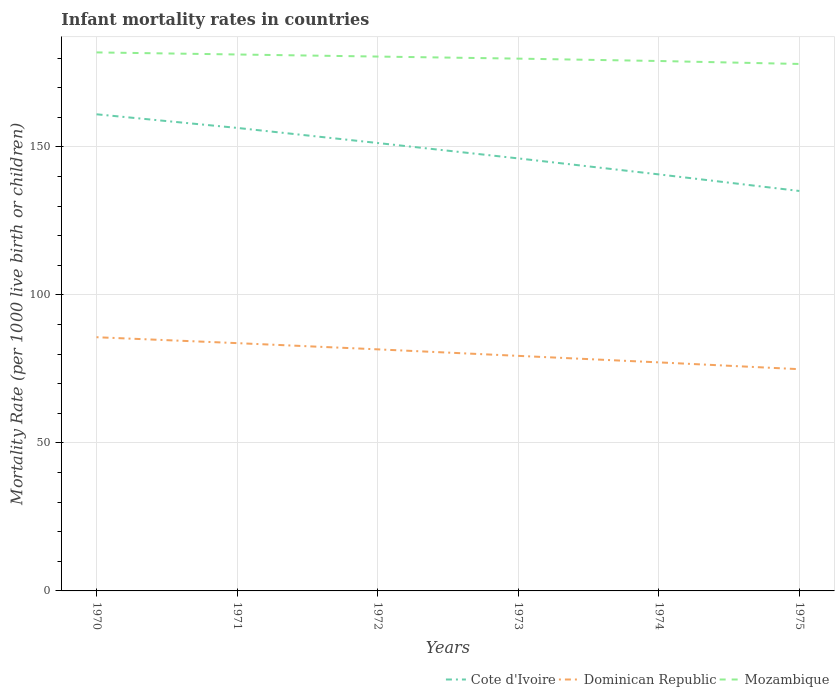Does the line corresponding to Mozambique intersect with the line corresponding to Cote d'Ivoire?
Keep it short and to the point. No. Across all years, what is the maximum infant mortality rate in Cote d'Ivoire?
Your answer should be compact. 135.1. In which year was the infant mortality rate in Dominican Republic maximum?
Make the answer very short. 1975. What is the total infant mortality rate in Dominican Republic in the graph?
Your answer should be compact. 2.2. What is the difference between the highest and the second highest infant mortality rate in Mozambique?
Your answer should be very brief. 3.9. What is the difference between the highest and the lowest infant mortality rate in Mozambique?
Give a very brief answer. 3. How many lines are there?
Offer a very short reply. 3. Does the graph contain grids?
Give a very brief answer. Yes. Where does the legend appear in the graph?
Your response must be concise. Bottom right. How many legend labels are there?
Your answer should be very brief. 3. What is the title of the graph?
Provide a succinct answer. Infant mortality rates in countries. Does "Fiji" appear as one of the legend labels in the graph?
Offer a very short reply. No. What is the label or title of the Y-axis?
Keep it short and to the point. Mortality Rate (per 1000 live birth or children). What is the Mortality Rate (per 1000 live birth or children) of Cote d'Ivoire in 1970?
Make the answer very short. 161. What is the Mortality Rate (per 1000 live birth or children) in Dominican Republic in 1970?
Provide a succinct answer. 85.7. What is the Mortality Rate (per 1000 live birth or children) in Mozambique in 1970?
Give a very brief answer. 181.9. What is the Mortality Rate (per 1000 live birth or children) of Cote d'Ivoire in 1971?
Give a very brief answer. 156.4. What is the Mortality Rate (per 1000 live birth or children) of Dominican Republic in 1971?
Your answer should be compact. 83.7. What is the Mortality Rate (per 1000 live birth or children) in Mozambique in 1971?
Your answer should be very brief. 181.2. What is the Mortality Rate (per 1000 live birth or children) in Cote d'Ivoire in 1972?
Your answer should be compact. 151.3. What is the Mortality Rate (per 1000 live birth or children) of Dominican Republic in 1972?
Your answer should be very brief. 81.6. What is the Mortality Rate (per 1000 live birth or children) of Mozambique in 1972?
Keep it short and to the point. 180.5. What is the Mortality Rate (per 1000 live birth or children) in Cote d'Ivoire in 1973?
Ensure brevity in your answer.  146.1. What is the Mortality Rate (per 1000 live birth or children) in Dominican Republic in 1973?
Your answer should be compact. 79.4. What is the Mortality Rate (per 1000 live birth or children) of Mozambique in 1973?
Keep it short and to the point. 179.8. What is the Mortality Rate (per 1000 live birth or children) in Cote d'Ivoire in 1974?
Give a very brief answer. 140.7. What is the Mortality Rate (per 1000 live birth or children) in Dominican Republic in 1974?
Offer a very short reply. 77.2. What is the Mortality Rate (per 1000 live birth or children) in Mozambique in 1974?
Your response must be concise. 179. What is the Mortality Rate (per 1000 live birth or children) of Cote d'Ivoire in 1975?
Give a very brief answer. 135.1. What is the Mortality Rate (per 1000 live birth or children) in Dominican Republic in 1975?
Keep it short and to the point. 74.9. What is the Mortality Rate (per 1000 live birth or children) of Mozambique in 1975?
Give a very brief answer. 178. Across all years, what is the maximum Mortality Rate (per 1000 live birth or children) in Cote d'Ivoire?
Your response must be concise. 161. Across all years, what is the maximum Mortality Rate (per 1000 live birth or children) in Dominican Republic?
Provide a succinct answer. 85.7. Across all years, what is the maximum Mortality Rate (per 1000 live birth or children) in Mozambique?
Offer a terse response. 181.9. Across all years, what is the minimum Mortality Rate (per 1000 live birth or children) of Cote d'Ivoire?
Give a very brief answer. 135.1. Across all years, what is the minimum Mortality Rate (per 1000 live birth or children) in Dominican Republic?
Keep it short and to the point. 74.9. Across all years, what is the minimum Mortality Rate (per 1000 live birth or children) of Mozambique?
Your answer should be very brief. 178. What is the total Mortality Rate (per 1000 live birth or children) in Cote d'Ivoire in the graph?
Your answer should be compact. 890.6. What is the total Mortality Rate (per 1000 live birth or children) of Dominican Republic in the graph?
Keep it short and to the point. 482.5. What is the total Mortality Rate (per 1000 live birth or children) of Mozambique in the graph?
Your answer should be compact. 1080.4. What is the difference between the Mortality Rate (per 1000 live birth or children) of Cote d'Ivoire in 1970 and that in 1971?
Keep it short and to the point. 4.6. What is the difference between the Mortality Rate (per 1000 live birth or children) of Dominican Republic in 1970 and that in 1972?
Provide a short and direct response. 4.1. What is the difference between the Mortality Rate (per 1000 live birth or children) of Mozambique in 1970 and that in 1972?
Provide a succinct answer. 1.4. What is the difference between the Mortality Rate (per 1000 live birth or children) of Cote d'Ivoire in 1970 and that in 1974?
Make the answer very short. 20.3. What is the difference between the Mortality Rate (per 1000 live birth or children) of Mozambique in 1970 and that in 1974?
Provide a short and direct response. 2.9. What is the difference between the Mortality Rate (per 1000 live birth or children) in Cote d'Ivoire in 1970 and that in 1975?
Offer a very short reply. 25.9. What is the difference between the Mortality Rate (per 1000 live birth or children) in Dominican Republic in 1970 and that in 1975?
Your response must be concise. 10.8. What is the difference between the Mortality Rate (per 1000 live birth or children) of Cote d'Ivoire in 1971 and that in 1972?
Your answer should be very brief. 5.1. What is the difference between the Mortality Rate (per 1000 live birth or children) in Mozambique in 1971 and that in 1972?
Offer a terse response. 0.7. What is the difference between the Mortality Rate (per 1000 live birth or children) in Cote d'Ivoire in 1971 and that in 1973?
Provide a short and direct response. 10.3. What is the difference between the Mortality Rate (per 1000 live birth or children) in Cote d'Ivoire in 1971 and that in 1974?
Offer a terse response. 15.7. What is the difference between the Mortality Rate (per 1000 live birth or children) of Dominican Republic in 1971 and that in 1974?
Make the answer very short. 6.5. What is the difference between the Mortality Rate (per 1000 live birth or children) in Cote d'Ivoire in 1971 and that in 1975?
Offer a terse response. 21.3. What is the difference between the Mortality Rate (per 1000 live birth or children) in Mozambique in 1971 and that in 1975?
Keep it short and to the point. 3.2. What is the difference between the Mortality Rate (per 1000 live birth or children) in Cote d'Ivoire in 1972 and that in 1973?
Your answer should be very brief. 5.2. What is the difference between the Mortality Rate (per 1000 live birth or children) in Dominican Republic in 1972 and that in 1973?
Your answer should be very brief. 2.2. What is the difference between the Mortality Rate (per 1000 live birth or children) in Mozambique in 1972 and that in 1973?
Provide a short and direct response. 0.7. What is the difference between the Mortality Rate (per 1000 live birth or children) of Dominican Republic in 1972 and that in 1974?
Give a very brief answer. 4.4. What is the difference between the Mortality Rate (per 1000 live birth or children) in Dominican Republic in 1972 and that in 1975?
Your response must be concise. 6.7. What is the difference between the Mortality Rate (per 1000 live birth or children) of Cote d'Ivoire in 1973 and that in 1974?
Provide a succinct answer. 5.4. What is the difference between the Mortality Rate (per 1000 live birth or children) of Dominican Republic in 1973 and that in 1974?
Your response must be concise. 2.2. What is the difference between the Mortality Rate (per 1000 live birth or children) of Dominican Republic in 1973 and that in 1975?
Your answer should be compact. 4.5. What is the difference between the Mortality Rate (per 1000 live birth or children) of Mozambique in 1973 and that in 1975?
Keep it short and to the point. 1.8. What is the difference between the Mortality Rate (per 1000 live birth or children) of Dominican Republic in 1974 and that in 1975?
Your answer should be very brief. 2.3. What is the difference between the Mortality Rate (per 1000 live birth or children) of Cote d'Ivoire in 1970 and the Mortality Rate (per 1000 live birth or children) of Dominican Republic in 1971?
Give a very brief answer. 77.3. What is the difference between the Mortality Rate (per 1000 live birth or children) of Cote d'Ivoire in 1970 and the Mortality Rate (per 1000 live birth or children) of Mozambique in 1971?
Offer a very short reply. -20.2. What is the difference between the Mortality Rate (per 1000 live birth or children) of Dominican Republic in 1970 and the Mortality Rate (per 1000 live birth or children) of Mozambique in 1971?
Offer a very short reply. -95.5. What is the difference between the Mortality Rate (per 1000 live birth or children) of Cote d'Ivoire in 1970 and the Mortality Rate (per 1000 live birth or children) of Dominican Republic in 1972?
Provide a succinct answer. 79.4. What is the difference between the Mortality Rate (per 1000 live birth or children) in Cote d'Ivoire in 1970 and the Mortality Rate (per 1000 live birth or children) in Mozambique in 1972?
Your answer should be very brief. -19.5. What is the difference between the Mortality Rate (per 1000 live birth or children) of Dominican Republic in 1970 and the Mortality Rate (per 1000 live birth or children) of Mozambique in 1972?
Make the answer very short. -94.8. What is the difference between the Mortality Rate (per 1000 live birth or children) of Cote d'Ivoire in 1970 and the Mortality Rate (per 1000 live birth or children) of Dominican Republic in 1973?
Keep it short and to the point. 81.6. What is the difference between the Mortality Rate (per 1000 live birth or children) of Cote d'Ivoire in 1970 and the Mortality Rate (per 1000 live birth or children) of Mozambique in 1973?
Your response must be concise. -18.8. What is the difference between the Mortality Rate (per 1000 live birth or children) in Dominican Republic in 1970 and the Mortality Rate (per 1000 live birth or children) in Mozambique in 1973?
Give a very brief answer. -94.1. What is the difference between the Mortality Rate (per 1000 live birth or children) of Cote d'Ivoire in 1970 and the Mortality Rate (per 1000 live birth or children) of Dominican Republic in 1974?
Provide a short and direct response. 83.8. What is the difference between the Mortality Rate (per 1000 live birth or children) of Cote d'Ivoire in 1970 and the Mortality Rate (per 1000 live birth or children) of Mozambique in 1974?
Offer a terse response. -18. What is the difference between the Mortality Rate (per 1000 live birth or children) of Dominican Republic in 1970 and the Mortality Rate (per 1000 live birth or children) of Mozambique in 1974?
Offer a very short reply. -93.3. What is the difference between the Mortality Rate (per 1000 live birth or children) of Cote d'Ivoire in 1970 and the Mortality Rate (per 1000 live birth or children) of Dominican Republic in 1975?
Offer a very short reply. 86.1. What is the difference between the Mortality Rate (per 1000 live birth or children) of Cote d'Ivoire in 1970 and the Mortality Rate (per 1000 live birth or children) of Mozambique in 1975?
Your answer should be compact. -17. What is the difference between the Mortality Rate (per 1000 live birth or children) in Dominican Republic in 1970 and the Mortality Rate (per 1000 live birth or children) in Mozambique in 1975?
Your answer should be very brief. -92.3. What is the difference between the Mortality Rate (per 1000 live birth or children) of Cote d'Ivoire in 1971 and the Mortality Rate (per 1000 live birth or children) of Dominican Republic in 1972?
Ensure brevity in your answer.  74.8. What is the difference between the Mortality Rate (per 1000 live birth or children) of Cote d'Ivoire in 1971 and the Mortality Rate (per 1000 live birth or children) of Mozambique in 1972?
Your answer should be compact. -24.1. What is the difference between the Mortality Rate (per 1000 live birth or children) of Dominican Republic in 1971 and the Mortality Rate (per 1000 live birth or children) of Mozambique in 1972?
Give a very brief answer. -96.8. What is the difference between the Mortality Rate (per 1000 live birth or children) in Cote d'Ivoire in 1971 and the Mortality Rate (per 1000 live birth or children) in Dominican Republic in 1973?
Provide a short and direct response. 77. What is the difference between the Mortality Rate (per 1000 live birth or children) in Cote d'Ivoire in 1971 and the Mortality Rate (per 1000 live birth or children) in Mozambique in 1973?
Your response must be concise. -23.4. What is the difference between the Mortality Rate (per 1000 live birth or children) in Dominican Republic in 1971 and the Mortality Rate (per 1000 live birth or children) in Mozambique in 1973?
Your answer should be very brief. -96.1. What is the difference between the Mortality Rate (per 1000 live birth or children) of Cote d'Ivoire in 1971 and the Mortality Rate (per 1000 live birth or children) of Dominican Republic in 1974?
Ensure brevity in your answer.  79.2. What is the difference between the Mortality Rate (per 1000 live birth or children) in Cote d'Ivoire in 1971 and the Mortality Rate (per 1000 live birth or children) in Mozambique in 1974?
Offer a very short reply. -22.6. What is the difference between the Mortality Rate (per 1000 live birth or children) in Dominican Republic in 1971 and the Mortality Rate (per 1000 live birth or children) in Mozambique in 1974?
Ensure brevity in your answer.  -95.3. What is the difference between the Mortality Rate (per 1000 live birth or children) in Cote d'Ivoire in 1971 and the Mortality Rate (per 1000 live birth or children) in Dominican Republic in 1975?
Offer a terse response. 81.5. What is the difference between the Mortality Rate (per 1000 live birth or children) in Cote d'Ivoire in 1971 and the Mortality Rate (per 1000 live birth or children) in Mozambique in 1975?
Your answer should be compact. -21.6. What is the difference between the Mortality Rate (per 1000 live birth or children) of Dominican Republic in 1971 and the Mortality Rate (per 1000 live birth or children) of Mozambique in 1975?
Your answer should be compact. -94.3. What is the difference between the Mortality Rate (per 1000 live birth or children) in Cote d'Ivoire in 1972 and the Mortality Rate (per 1000 live birth or children) in Dominican Republic in 1973?
Keep it short and to the point. 71.9. What is the difference between the Mortality Rate (per 1000 live birth or children) in Cote d'Ivoire in 1972 and the Mortality Rate (per 1000 live birth or children) in Mozambique in 1973?
Your answer should be very brief. -28.5. What is the difference between the Mortality Rate (per 1000 live birth or children) of Dominican Republic in 1972 and the Mortality Rate (per 1000 live birth or children) of Mozambique in 1973?
Make the answer very short. -98.2. What is the difference between the Mortality Rate (per 1000 live birth or children) of Cote d'Ivoire in 1972 and the Mortality Rate (per 1000 live birth or children) of Dominican Republic in 1974?
Keep it short and to the point. 74.1. What is the difference between the Mortality Rate (per 1000 live birth or children) in Cote d'Ivoire in 1972 and the Mortality Rate (per 1000 live birth or children) in Mozambique in 1974?
Provide a succinct answer. -27.7. What is the difference between the Mortality Rate (per 1000 live birth or children) of Dominican Republic in 1972 and the Mortality Rate (per 1000 live birth or children) of Mozambique in 1974?
Ensure brevity in your answer.  -97.4. What is the difference between the Mortality Rate (per 1000 live birth or children) of Cote d'Ivoire in 1972 and the Mortality Rate (per 1000 live birth or children) of Dominican Republic in 1975?
Your answer should be compact. 76.4. What is the difference between the Mortality Rate (per 1000 live birth or children) of Cote d'Ivoire in 1972 and the Mortality Rate (per 1000 live birth or children) of Mozambique in 1975?
Give a very brief answer. -26.7. What is the difference between the Mortality Rate (per 1000 live birth or children) in Dominican Republic in 1972 and the Mortality Rate (per 1000 live birth or children) in Mozambique in 1975?
Your answer should be compact. -96.4. What is the difference between the Mortality Rate (per 1000 live birth or children) in Cote d'Ivoire in 1973 and the Mortality Rate (per 1000 live birth or children) in Dominican Republic in 1974?
Offer a very short reply. 68.9. What is the difference between the Mortality Rate (per 1000 live birth or children) of Cote d'Ivoire in 1973 and the Mortality Rate (per 1000 live birth or children) of Mozambique in 1974?
Ensure brevity in your answer.  -32.9. What is the difference between the Mortality Rate (per 1000 live birth or children) of Dominican Republic in 1973 and the Mortality Rate (per 1000 live birth or children) of Mozambique in 1974?
Your answer should be very brief. -99.6. What is the difference between the Mortality Rate (per 1000 live birth or children) of Cote d'Ivoire in 1973 and the Mortality Rate (per 1000 live birth or children) of Dominican Republic in 1975?
Give a very brief answer. 71.2. What is the difference between the Mortality Rate (per 1000 live birth or children) in Cote d'Ivoire in 1973 and the Mortality Rate (per 1000 live birth or children) in Mozambique in 1975?
Keep it short and to the point. -31.9. What is the difference between the Mortality Rate (per 1000 live birth or children) of Dominican Republic in 1973 and the Mortality Rate (per 1000 live birth or children) of Mozambique in 1975?
Give a very brief answer. -98.6. What is the difference between the Mortality Rate (per 1000 live birth or children) of Cote d'Ivoire in 1974 and the Mortality Rate (per 1000 live birth or children) of Dominican Republic in 1975?
Ensure brevity in your answer.  65.8. What is the difference between the Mortality Rate (per 1000 live birth or children) of Cote d'Ivoire in 1974 and the Mortality Rate (per 1000 live birth or children) of Mozambique in 1975?
Give a very brief answer. -37.3. What is the difference between the Mortality Rate (per 1000 live birth or children) of Dominican Republic in 1974 and the Mortality Rate (per 1000 live birth or children) of Mozambique in 1975?
Make the answer very short. -100.8. What is the average Mortality Rate (per 1000 live birth or children) in Cote d'Ivoire per year?
Offer a very short reply. 148.43. What is the average Mortality Rate (per 1000 live birth or children) of Dominican Republic per year?
Your answer should be compact. 80.42. What is the average Mortality Rate (per 1000 live birth or children) in Mozambique per year?
Provide a succinct answer. 180.07. In the year 1970, what is the difference between the Mortality Rate (per 1000 live birth or children) in Cote d'Ivoire and Mortality Rate (per 1000 live birth or children) in Dominican Republic?
Ensure brevity in your answer.  75.3. In the year 1970, what is the difference between the Mortality Rate (per 1000 live birth or children) of Cote d'Ivoire and Mortality Rate (per 1000 live birth or children) of Mozambique?
Your response must be concise. -20.9. In the year 1970, what is the difference between the Mortality Rate (per 1000 live birth or children) in Dominican Republic and Mortality Rate (per 1000 live birth or children) in Mozambique?
Your answer should be very brief. -96.2. In the year 1971, what is the difference between the Mortality Rate (per 1000 live birth or children) of Cote d'Ivoire and Mortality Rate (per 1000 live birth or children) of Dominican Republic?
Make the answer very short. 72.7. In the year 1971, what is the difference between the Mortality Rate (per 1000 live birth or children) of Cote d'Ivoire and Mortality Rate (per 1000 live birth or children) of Mozambique?
Your answer should be very brief. -24.8. In the year 1971, what is the difference between the Mortality Rate (per 1000 live birth or children) of Dominican Republic and Mortality Rate (per 1000 live birth or children) of Mozambique?
Offer a terse response. -97.5. In the year 1972, what is the difference between the Mortality Rate (per 1000 live birth or children) in Cote d'Ivoire and Mortality Rate (per 1000 live birth or children) in Dominican Republic?
Keep it short and to the point. 69.7. In the year 1972, what is the difference between the Mortality Rate (per 1000 live birth or children) in Cote d'Ivoire and Mortality Rate (per 1000 live birth or children) in Mozambique?
Your response must be concise. -29.2. In the year 1972, what is the difference between the Mortality Rate (per 1000 live birth or children) of Dominican Republic and Mortality Rate (per 1000 live birth or children) of Mozambique?
Ensure brevity in your answer.  -98.9. In the year 1973, what is the difference between the Mortality Rate (per 1000 live birth or children) of Cote d'Ivoire and Mortality Rate (per 1000 live birth or children) of Dominican Republic?
Your answer should be very brief. 66.7. In the year 1973, what is the difference between the Mortality Rate (per 1000 live birth or children) in Cote d'Ivoire and Mortality Rate (per 1000 live birth or children) in Mozambique?
Provide a short and direct response. -33.7. In the year 1973, what is the difference between the Mortality Rate (per 1000 live birth or children) in Dominican Republic and Mortality Rate (per 1000 live birth or children) in Mozambique?
Provide a succinct answer. -100.4. In the year 1974, what is the difference between the Mortality Rate (per 1000 live birth or children) in Cote d'Ivoire and Mortality Rate (per 1000 live birth or children) in Dominican Republic?
Your answer should be compact. 63.5. In the year 1974, what is the difference between the Mortality Rate (per 1000 live birth or children) in Cote d'Ivoire and Mortality Rate (per 1000 live birth or children) in Mozambique?
Your answer should be very brief. -38.3. In the year 1974, what is the difference between the Mortality Rate (per 1000 live birth or children) of Dominican Republic and Mortality Rate (per 1000 live birth or children) of Mozambique?
Your response must be concise. -101.8. In the year 1975, what is the difference between the Mortality Rate (per 1000 live birth or children) in Cote d'Ivoire and Mortality Rate (per 1000 live birth or children) in Dominican Republic?
Your response must be concise. 60.2. In the year 1975, what is the difference between the Mortality Rate (per 1000 live birth or children) of Cote d'Ivoire and Mortality Rate (per 1000 live birth or children) of Mozambique?
Ensure brevity in your answer.  -42.9. In the year 1975, what is the difference between the Mortality Rate (per 1000 live birth or children) in Dominican Republic and Mortality Rate (per 1000 live birth or children) in Mozambique?
Your answer should be compact. -103.1. What is the ratio of the Mortality Rate (per 1000 live birth or children) in Cote d'Ivoire in 1970 to that in 1971?
Offer a very short reply. 1.03. What is the ratio of the Mortality Rate (per 1000 live birth or children) in Dominican Republic in 1970 to that in 1971?
Provide a short and direct response. 1.02. What is the ratio of the Mortality Rate (per 1000 live birth or children) of Mozambique in 1970 to that in 1971?
Your answer should be very brief. 1. What is the ratio of the Mortality Rate (per 1000 live birth or children) in Cote d'Ivoire in 1970 to that in 1972?
Your answer should be very brief. 1.06. What is the ratio of the Mortality Rate (per 1000 live birth or children) in Dominican Republic in 1970 to that in 1972?
Your response must be concise. 1.05. What is the ratio of the Mortality Rate (per 1000 live birth or children) in Cote d'Ivoire in 1970 to that in 1973?
Make the answer very short. 1.1. What is the ratio of the Mortality Rate (per 1000 live birth or children) of Dominican Republic in 1970 to that in 1973?
Ensure brevity in your answer.  1.08. What is the ratio of the Mortality Rate (per 1000 live birth or children) in Mozambique in 1970 to that in 1973?
Give a very brief answer. 1.01. What is the ratio of the Mortality Rate (per 1000 live birth or children) in Cote d'Ivoire in 1970 to that in 1974?
Keep it short and to the point. 1.14. What is the ratio of the Mortality Rate (per 1000 live birth or children) of Dominican Republic in 1970 to that in 1974?
Offer a terse response. 1.11. What is the ratio of the Mortality Rate (per 1000 live birth or children) in Mozambique in 1970 to that in 1974?
Offer a very short reply. 1.02. What is the ratio of the Mortality Rate (per 1000 live birth or children) of Cote d'Ivoire in 1970 to that in 1975?
Give a very brief answer. 1.19. What is the ratio of the Mortality Rate (per 1000 live birth or children) in Dominican Republic in 1970 to that in 1975?
Offer a very short reply. 1.14. What is the ratio of the Mortality Rate (per 1000 live birth or children) in Mozambique in 1970 to that in 1975?
Make the answer very short. 1.02. What is the ratio of the Mortality Rate (per 1000 live birth or children) of Cote d'Ivoire in 1971 to that in 1972?
Provide a short and direct response. 1.03. What is the ratio of the Mortality Rate (per 1000 live birth or children) of Dominican Republic in 1971 to that in 1972?
Your answer should be very brief. 1.03. What is the ratio of the Mortality Rate (per 1000 live birth or children) in Mozambique in 1971 to that in 1972?
Keep it short and to the point. 1. What is the ratio of the Mortality Rate (per 1000 live birth or children) of Cote d'Ivoire in 1971 to that in 1973?
Your answer should be very brief. 1.07. What is the ratio of the Mortality Rate (per 1000 live birth or children) in Dominican Republic in 1971 to that in 1973?
Offer a very short reply. 1.05. What is the ratio of the Mortality Rate (per 1000 live birth or children) in Mozambique in 1971 to that in 1973?
Give a very brief answer. 1.01. What is the ratio of the Mortality Rate (per 1000 live birth or children) of Cote d'Ivoire in 1971 to that in 1974?
Make the answer very short. 1.11. What is the ratio of the Mortality Rate (per 1000 live birth or children) in Dominican Republic in 1971 to that in 1974?
Ensure brevity in your answer.  1.08. What is the ratio of the Mortality Rate (per 1000 live birth or children) in Mozambique in 1971 to that in 1974?
Ensure brevity in your answer.  1.01. What is the ratio of the Mortality Rate (per 1000 live birth or children) in Cote d'Ivoire in 1971 to that in 1975?
Your answer should be very brief. 1.16. What is the ratio of the Mortality Rate (per 1000 live birth or children) of Dominican Republic in 1971 to that in 1975?
Your response must be concise. 1.12. What is the ratio of the Mortality Rate (per 1000 live birth or children) in Cote d'Ivoire in 1972 to that in 1973?
Your answer should be very brief. 1.04. What is the ratio of the Mortality Rate (per 1000 live birth or children) in Dominican Republic in 1972 to that in 1973?
Your response must be concise. 1.03. What is the ratio of the Mortality Rate (per 1000 live birth or children) in Cote d'Ivoire in 1972 to that in 1974?
Keep it short and to the point. 1.08. What is the ratio of the Mortality Rate (per 1000 live birth or children) in Dominican Republic in 1972 to that in 1974?
Your answer should be compact. 1.06. What is the ratio of the Mortality Rate (per 1000 live birth or children) in Mozambique in 1972 to that in 1974?
Your answer should be very brief. 1.01. What is the ratio of the Mortality Rate (per 1000 live birth or children) of Cote d'Ivoire in 1972 to that in 1975?
Keep it short and to the point. 1.12. What is the ratio of the Mortality Rate (per 1000 live birth or children) of Dominican Republic in 1972 to that in 1975?
Give a very brief answer. 1.09. What is the ratio of the Mortality Rate (per 1000 live birth or children) in Cote d'Ivoire in 1973 to that in 1974?
Offer a very short reply. 1.04. What is the ratio of the Mortality Rate (per 1000 live birth or children) of Dominican Republic in 1973 to that in 1974?
Your response must be concise. 1.03. What is the ratio of the Mortality Rate (per 1000 live birth or children) of Mozambique in 1973 to that in 1974?
Ensure brevity in your answer.  1. What is the ratio of the Mortality Rate (per 1000 live birth or children) in Cote d'Ivoire in 1973 to that in 1975?
Keep it short and to the point. 1.08. What is the ratio of the Mortality Rate (per 1000 live birth or children) in Dominican Republic in 1973 to that in 1975?
Ensure brevity in your answer.  1.06. What is the ratio of the Mortality Rate (per 1000 live birth or children) in Mozambique in 1973 to that in 1975?
Give a very brief answer. 1.01. What is the ratio of the Mortality Rate (per 1000 live birth or children) in Cote d'Ivoire in 1974 to that in 1975?
Provide a succinct answer. 1.04. What is the ratio of the Mortality Rate (per 1000 live birth or children) in Dominican Republic in 1974 to that in 1975?
Give a very brief answer. 1.03. What is the ratio of the Mortality Rate (per 1000 live birth or children) in Mozambique in 1974 to that in 1975?
Your answer should be very brief. 1.01. What is the difference between the highest and the lowest Mortality Rate (per 1000 live birth or children) of Cote d'Ivoire?
Provide a succinct answer. 25.9. What is the difference between the highest and the lowest Mortality Rate (per 1000 live birth or children) in Dominican Republic?
Offer a very short reply. 10.8. 